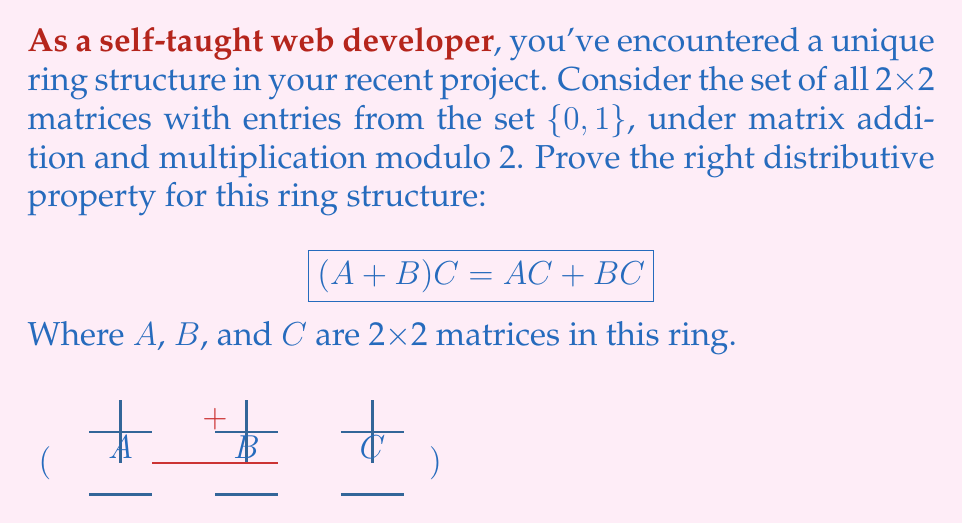Show me your answer to this math problem. Let's prove this step-by-step:

1) First, let's represent our matrices in general form:

   $$A = \begin{pmatrix} a_{11} & a_{12} \\ a_{21} & a_{22} \end{pmatrix},
     B = \begin{pmatrix} b_{11} & b_{12} \\ b_{21} & b_{22} \end{pmatrix},
     C = \begin{pmatrix} c_{11} & c_{12} \\ c_{21} & c_{22} \end{pmatrix}$$

   Where all $a_{ij}, b_{ij}, c_{ij} \in \{0, 1\}$

2) Let's calculate the left side of the equation, $(A + B)C$:

   $A + B = \begin{pmatrix} (a_{11} + b_{11}) \bmod 2 & (a_{12} + b_{12}) \bmod 2 \\ (a_{21} + b_{21}) \bmod 2 & (a_{22} + b_{22}) \bmod 2 \end{pmatrix}$

3) Now multiply this result by C:

   $(A + B)C = \begin{pmatrix} 
   ((a_{11} + b_{11})c_{11} + (a_{12} + b_{12})c_{21}) \bmod 2 & ((a_{11} + b_{11})c_{12} + (a_{12} + b_{12})c_{22}) \bmod 2 \\
   ((a_{21} + b_{21})c_{11} + (a_{22} + b_{22})c_{21}) \bmod 2 & ((a_{21} + b_{21})c_{12} + (a_{22} + b_{22})c_{22}) \bmod 2
   \end{pmatrix}$

4) Now, let's calculate the right side of the equation, $AC + BC$:

   $AC = \begin{pmatrix} 
   (a_{11}c_{11} + a_{12}c_{21}) \bmod 2 & (a_{11}c_{12} + a_{12}c_{22}) \bmod 2 \\
   (a_{21}c_{11} + a_{22}c_{21}) \bmod 2 & (a_{21}c_{12} + a_{22}c_{22}) \bmod 2
   \end{pmatrix}$

   $BC = \begin{pmatrix} 
   (b_{11}c_{11} + b_{12}c_{21}) \bmod 2 & (b_{11}c_{12} + b_{12}c_{22}) \bmod 2 \\
   (b_{21}c_{11} + b_{22}c_{21}) \bmod 2 & (b_{21}c_{12} + b_{22}c_{22}) \bmod 2
   \end{pmatrix}$

5) Adding these matrices:

   $AC + BC = \begin{pmatrix} 
   ((a_{11}c_{11} + a_{12}c_{21}) + (b_{11}c_{11} + b_{12}c_{21})) \bmod 2 & ((a_{11}c_{12} + a_{12}c_{22}) + (b_{11}c_{12} + b_{12}c_{22})) \bmod 2 \\
   ((a_{21}c_{11} + a_{22}c_{21}) + (b_{21}c_{11} + b_{22}c_{21})) \bmod 2 & ((a_{21}c_{12} + a_{22}c_{22}) + (b_{21}c_{12} + b_{22}c_{22})) \bmod 2
   \end{pmatrix}$

6) Comparing the results from steps 3 and 5, we can see that they are equivalent. This is because:
   - Addition modulo 2 is associative and commutative
   - Multiplication distributes over addition in modular arithmetic

Therefore, we have proven that $(A + B)C = AC + BC$ for this ring structure.
Answer: $(A + B)C = AC + BC$ holds for 2x2 matrices with entries in $\{0, 1\}$ under matrix operations modulo 2. 